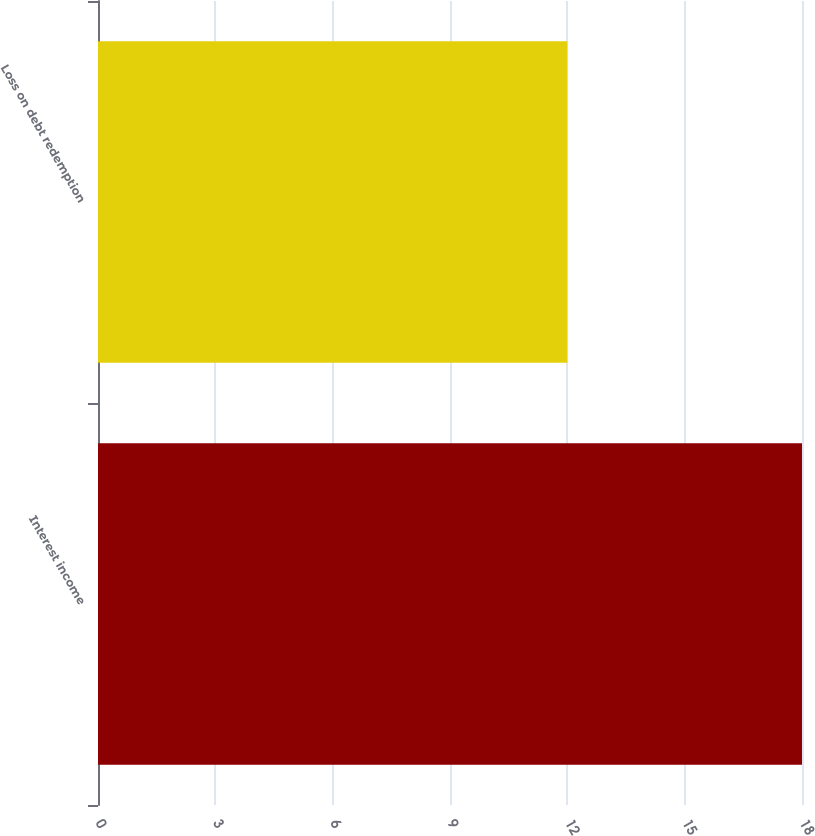Convert chart. <chart><loc_0><loc_0><loc_500><loc_500><bar_chart><fcel>Interest income<fcel>Loss on debt redemption<nl><fcel>18<fcel>12<nl></chart> 